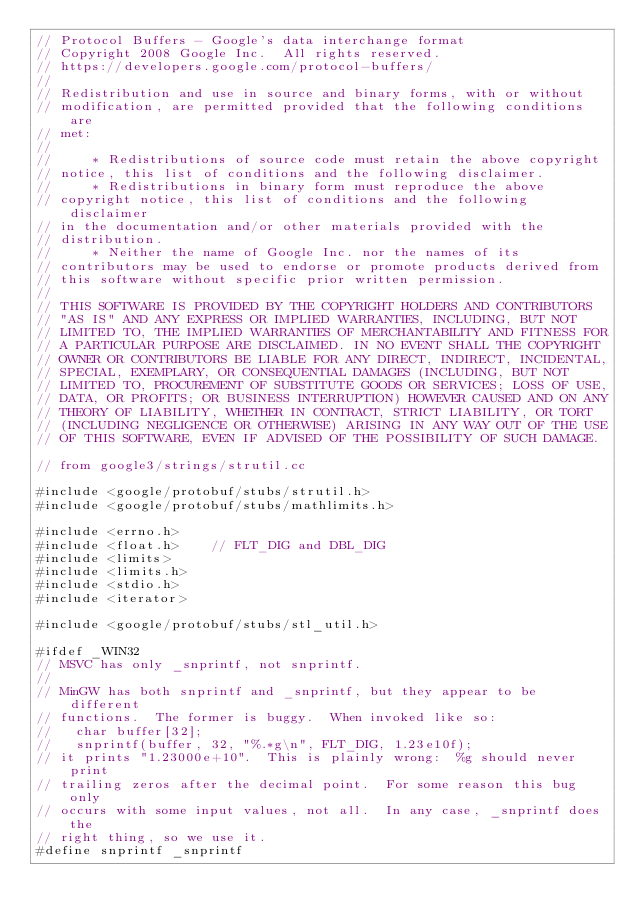Convert code to text. <code><loc_0><loc_0><loc_500><loc_500><_C++_>// Protocol Buffers - Google's data interchange format
// Copyright 2008 Google Inc.  All rights reserved.
// https://developers.google.com/protocol-buffers/
//
// Redistribution and use in source and binary forms, with or without
// modification, are permitted provided that the following conditions are
// met:
//
//     * Redistributions of source code must retain the above copyright
// notice, this list of conditions and the following disclaimer.
//     * Redistributions in binary form must reproduce the above
// copyright notice, this list of conditions and the following disclaimer
// in the documentation and/or other materials provided with the
// distribution.
//     * Neither the name of Google Inc. nor the names of its
// contributors may be used to endorse or promote products derived from
// this software without specific prior written permission.
//
// THIS SOFTWARE IS PROVIDED BY THE COPYRIGHT HOLDERS AND CONTRIBUTORS
// "AS IS" AND ANY EXPRESS OR IMPLIED WARRANTIES, INCLUDING, BUT NOT
// LIMITED TO, THE IMPLIED WARRANTIES OF MERCHANTABILITY AND FITNESS FOR
// A PARTICULAR PURPOSE ARE DISCLAIMED. IN NO EVENT SHALL THE COPYRIGHT
// OWNER OR CONTRIBUTORS BE LIABLE FOR ANY DIRECT, INDIRECT, INCIDENTAL,
// SPECIAL, EXEMPLARY, OR CONSEQUENTIAL DAMAGES (INCLUDING, BUT NOT
// LIMITED TO, PROCUREMENT OF SUBSTITUTE GOODS OR SERVICES; LOSS OF USE,
// DATA, OR PROFITS; OR BUSINESS INTERRUPTION) HOWEVER CAUSED AND ON ANY
// THEORY OF LIABILITY, WHETHER IN CONTRACT, STRICT LIABILITY, OR TORT
// (INCLUDING NEGLIGENCE OR OTHERWISE) ARISING IN ANY WAY OUT OF THE USE
// OF THIS SOFTWARE, EVEN IF ADVISED OF THE POSSIBILITY OF SUCH DAMAGE.

// from google3/strings/strutil.cc

#include <google/protobuf/stubs/strutil.h>
#include <google/protobuf/stubs/mathlimits.h>

#include <errno.h>
#include <float.h>    // FLT_DIG and DBL_DIG
#include <limits>
#include <limits.h>
#include <stdio.h>
#include <iterator>

#include <google/protobuf/stubs/stl_util.h>

#ifdef _WIN32
// MSVC has only _snprintf, not snprintf.
//
// MinGW has both snprintf and _snprintf, but they appear to be different
// functions.  The former is buggy.  When invoked like so:
//   char buffer[32];
//   snprintf(buffer, 32, "%.*g\n", FLT_DIG, 1.23e10f);
// it prints "1.23000e+10".  This is plainly wrong:  %g should never print
// trailing zeros after the decimal point.  For some reason this bug only
// occurs with some input values, not all.  In any case, _snprintf does the
// right thing, so we use it.
#define snprintf _snprintf</code> 